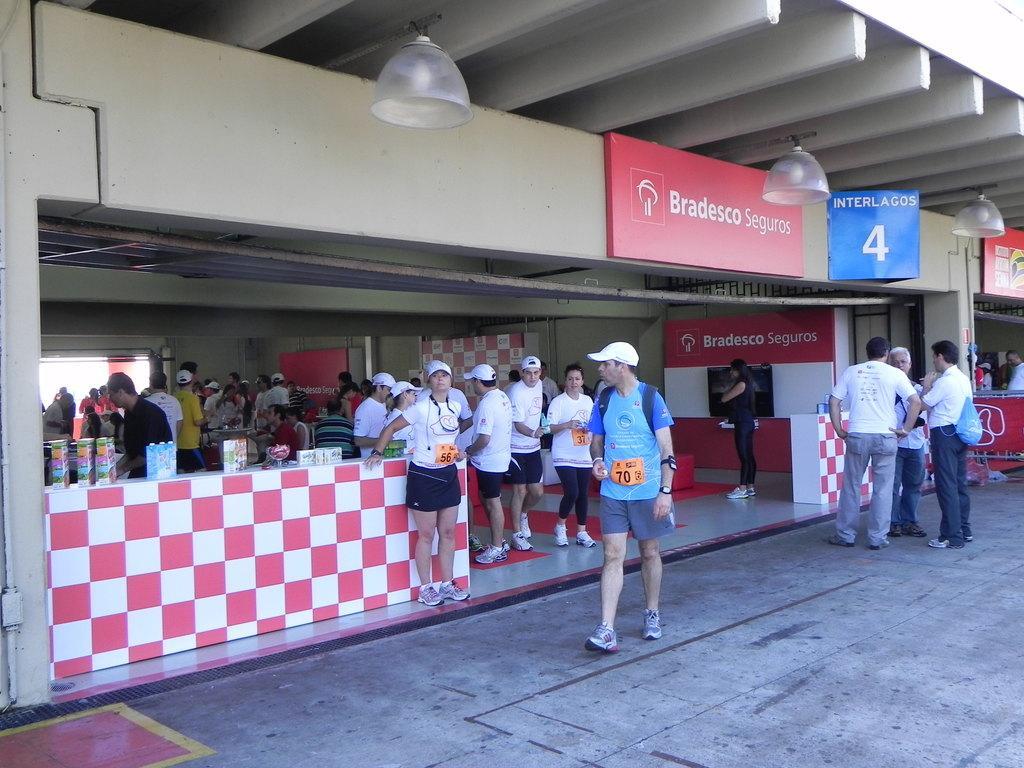In one or two sentences, can you explain what this image depicts? In the picture we can see a restaurant near it we can see some people are standing in a sports wear and inside it we can see some people are sitting near the tables and to the ceiling we can see the lights and we can see the board named as Bradesco seguros. 